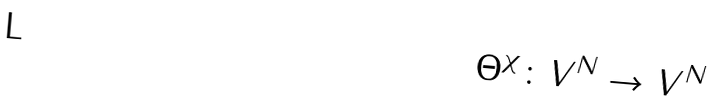<formula> <loc_0><loc_0><loc_500><loc_500>\Theta ^ { \chi } \colon V ^ { N } \rightarrow V ^ { N }</formula> 